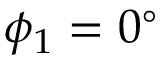Convert formula to latex. <formula><loc_0><loc_0><loc_500><loc_500>\phi _ { 1 } = 0 ^ { \circ }</formula> 